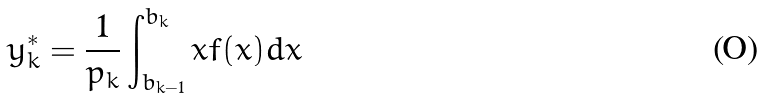<formula> <loc_0><loc_0><loc_500><loc_500>y _ { k } ^ { * } = { \frac { 1 } { p _ { k } } } \int _ { b _ { k - 1 } } ^ { b _ { k } } x f ( x ) d x</formula> 